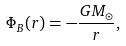Convert formula to latex. <formula><loc_0><loc_0><loc_500><loc_500>\Phi _ { B } ( r ) = - \frac { G M _ { \odot } } { r } ,</formula> 